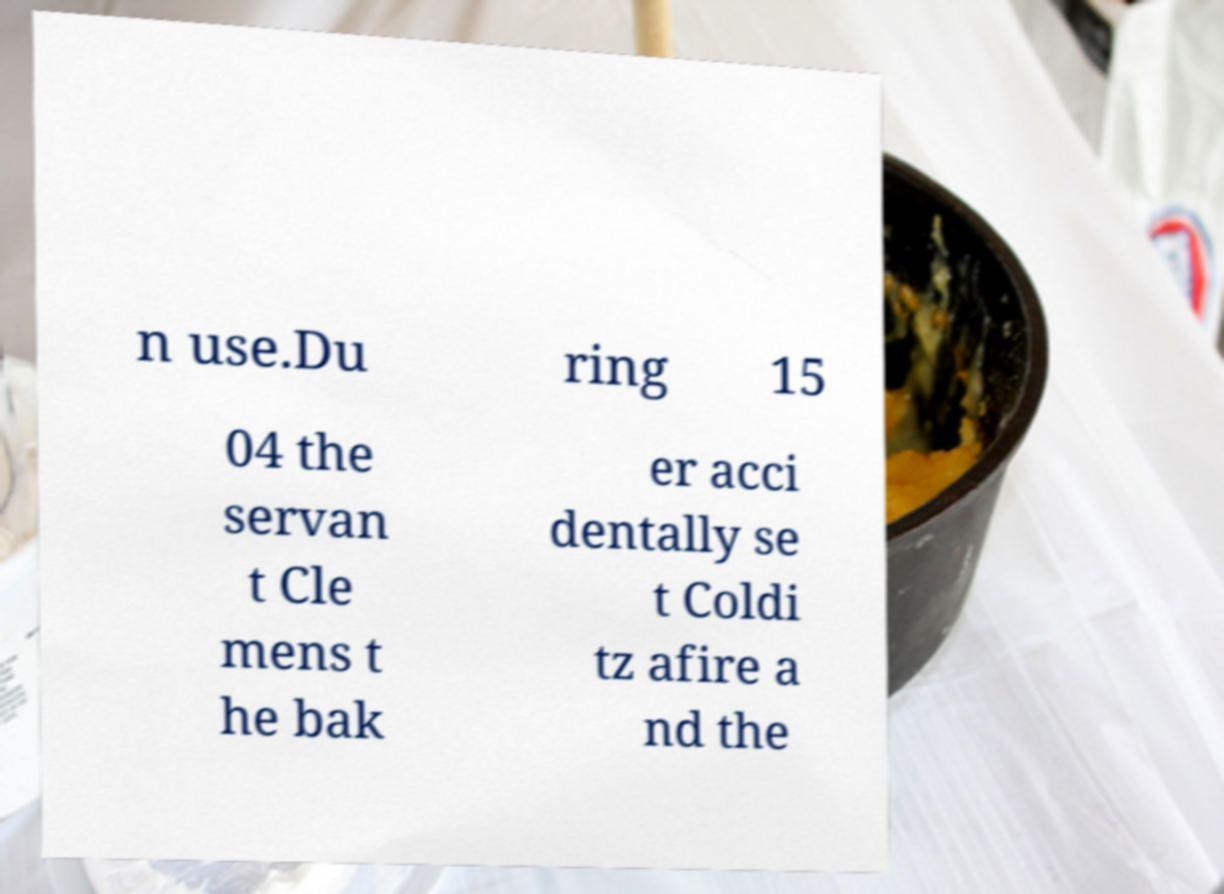Please identify and transcribe the text found in this image. n use.Du ring 15 04 the servan t Cle mens t he bak er acci dentally se t Coldi tz afire a nd the 